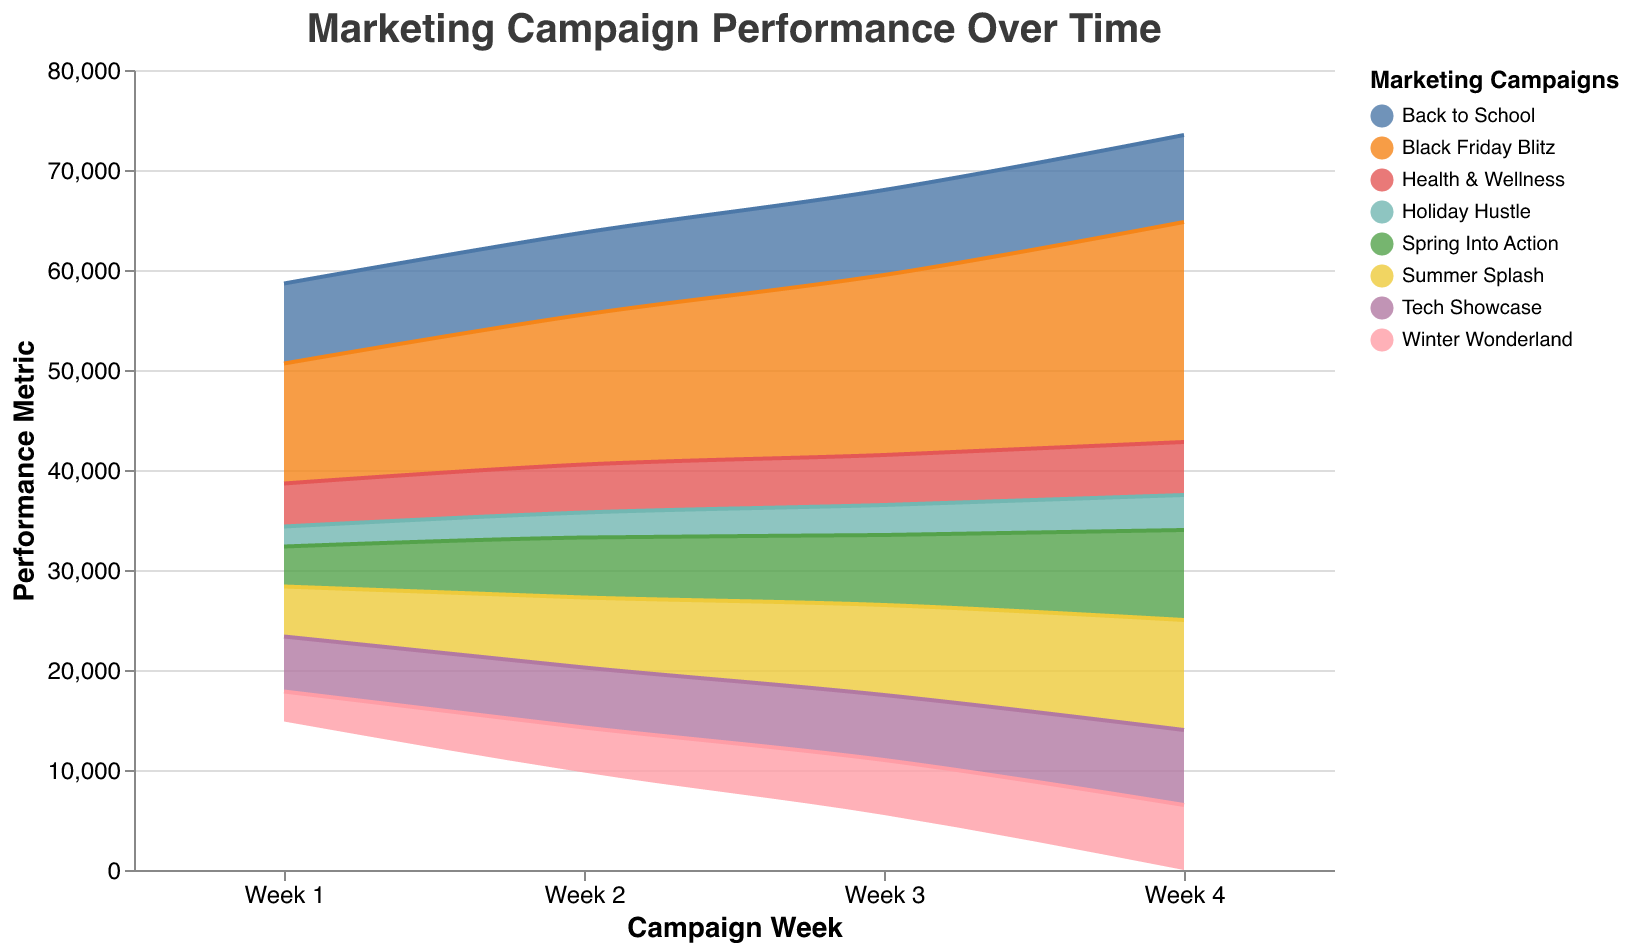What is the title of the figure? The title is prominently displayed at the top of the figure. It reads "Marketing Campaign Performance Over Time."
Answer: Marketing Campaign Performance Over Time How many marketing campaigns are represented in the graph? By looking at the legend on the right side, we can count the number of different campaigns, which are color-coded.
Answer: 8 Which campaign had the highest performance metric in Week 4? Looking at the Stream graph for Week 4, we can see that "Black Friday Blitz" occupies the largest area, indicating the highest value.
Answer: Black Friday Blitz What is the performance metric of "Holiday Hustle" in Week 2? Using the legend to identify "Holiday Hustle" and then tracing it to Week 2, we can see the metric.
Answer: 2500 By how much did the performance of "Tech Showcase" increase from Week 1 to Week 4? We need to subtract the value in Week 1 from the value in Week 4 for the "Tech Showcase" campaign. That is, 7500 - 5500 = 2000.
Answer: 2000 Which campaign exhibits the smallest increase in performance from Week 1 to Week 4? By calculating the difference between Week 1 and Week 4 for each campaign and comparing them, "Holiday Hustle" has the smallest increase (3500 - 2000 = 1500).
Answer: Holiday Hustle Which campaign showed consistent growth across all weeks without any decline? By observing the trends for each campaign, "Black Friday Blitz" shows a consistent upward trend without any week-to-week decline.
Answer: Black Friday Blitz What is the combined performance metric of "Summer Splash" and "Winter Wonderland" in Week 3? Adding the values of "Summer Splash" and "Winter Wonderland" in Week 3, we get 9000 + 5500 = 14500.
Answer: 14500 Of the campaigns, which two have the closest performance metrics in Week 1? Comparing the values in Week 1 for all campaigns, "Tech Showcase" (5500) and "Health & Wellness" (4300) have the metrics 5500 and 4300, giving the closest difference (1200).
Answer: Tech Showcase and Health & Wellness Calculate the average performance metric for "Back to School" over the four weeks. Adding the values for "Back to School" over four weeks (8000 + 8200 + 8500 + 8700) and then dividing by 4 gives (8000 + 8200 + 8500 + 8700)/4 = 8350.
Answer: 8350 